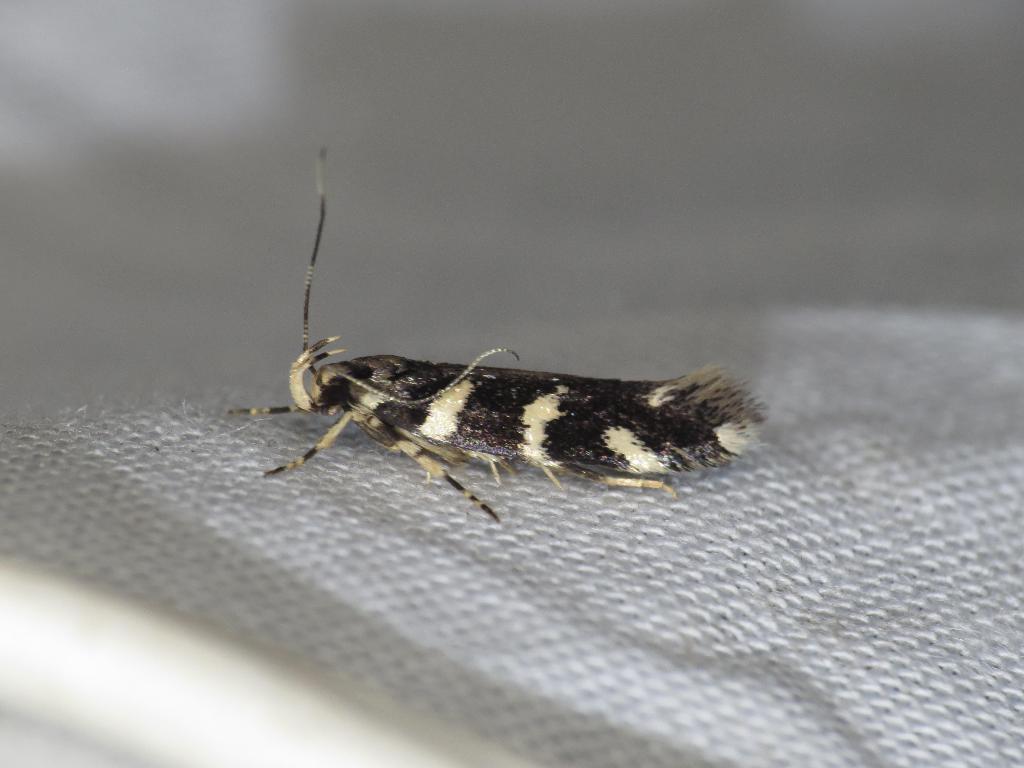Could you give a brief overview of what you see in this image? The insect shown in the picture is alypia octomaculata. 